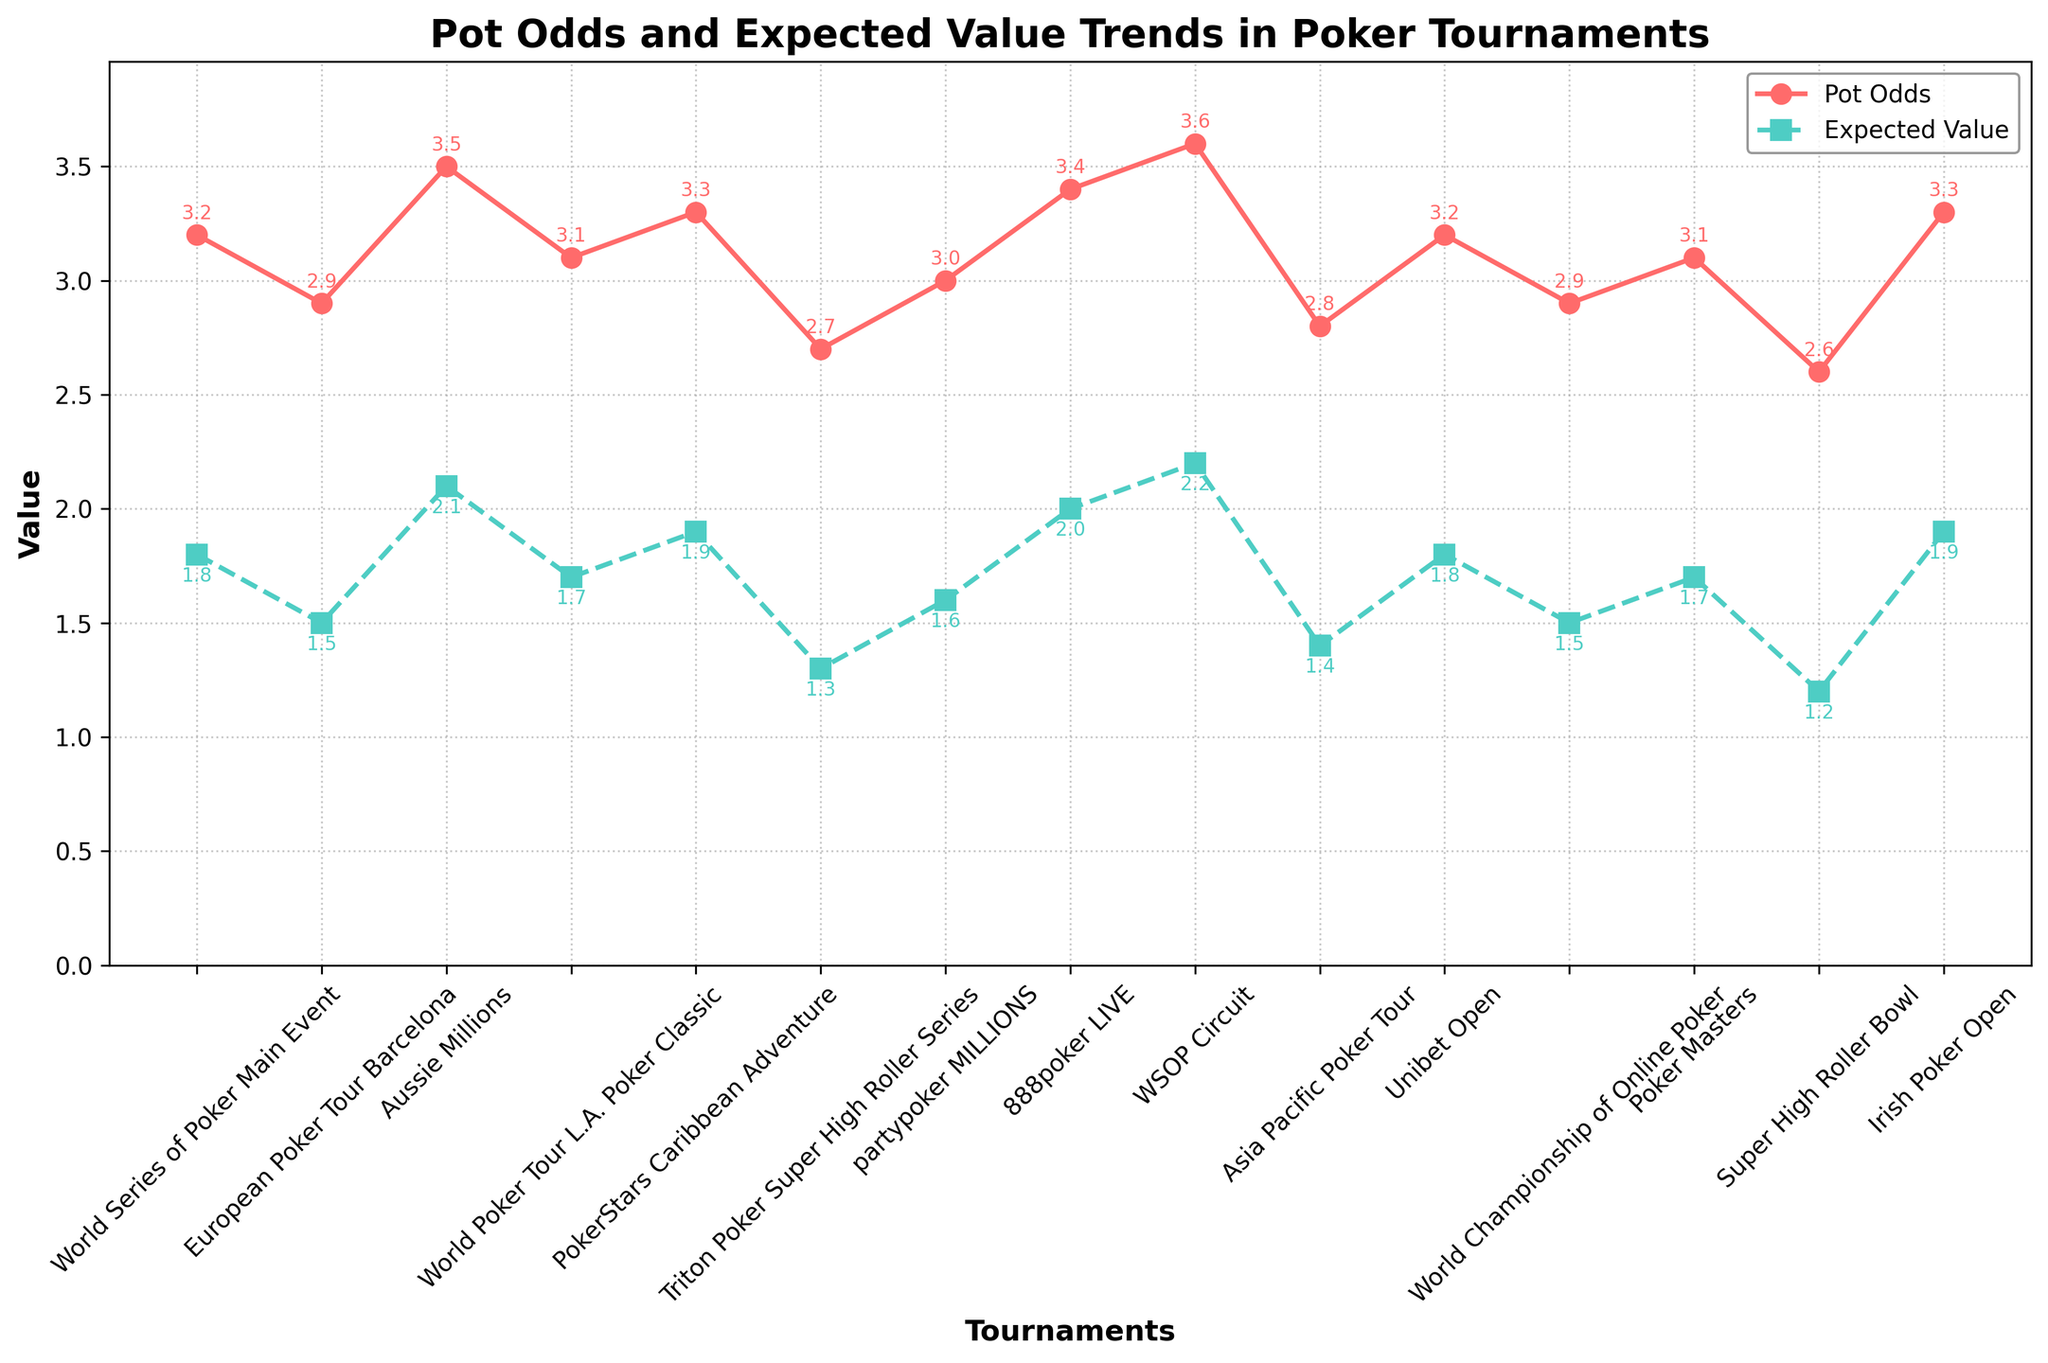What is the difference between the highest and lowest Pot Odds values? The highest Pot Odds value is 3.6 (WSOP Circuit) and the lowest is 2.6 (Super High Roller Bowl). The difference is calculated as 3.6 - 2.6 = 1.0
Answer: 1.0 Which tournament has the highest Expected Value? Looking at the Expected Value trendline, the WSOP Circuit has the highest Expected Value at 2.2
Answer: WSOP Circuit Are there any tournaments where the Pot Odds and Expected Value are identical? By examining the annotated numbers on the plots, no tournament shows identical Pot Odds and Expected Value values. The closest pairs differ by at least 0.1
Answer: No Which tournament has the lowest Pot Odds, and what is the corresponding Expected Value? The Super High Roller Bowl has the lowest Pot Odds at 2.6. The corresponding Expected Value for this tournament is 1.2
Answer: Super High Roller Bowl, 1.2 What is the average Expected Value across all tournaments? Sum all Expected Values: 1.8 + 1.5 + 2.1 + 1.7 + 1.9 + 1.3 + 1.6 + 2.0 + 2.2 + 1.4 + 1.8 + 1.5 + 1.7 + 1.2 + 1.9 = 26.6. The number of tournaments is 15. The average is calculated as 26.6 / 15 = 1.77
Answer: 1.77 How do the Pot Odds of the World Series of Poker Main Event compare to the Expected Value of the PokerStars Caribbean Adventure? The Pot Odds for the World Series of Poker Main Event is 3.2, while the Expected Value of the PokerStars Caribbean Adventure is 1.9. Therefore, the Pot Odds for the Main Event is greater
Answer: Greater Which tournament has the highest Pot Odds, and how does its Expected Value rank among all tournaments? The WSOP Circuit has the highest Pot Odds at 3.6. Its Expected Value is 2.2, which is the highest among all tournaments
Answer: WSOP Circuit, highest Do any tournaments show a Pot Odds value of exactly 3.0? Yes, the partypoker MILLIONS shows a Pot Odds value exactly at 3.0
Answer: Yes In which tournament does the Expected Value differ the most compared to its Pot Odds? The biggest difference between Pot Odds and Expected Value can be found by comparing the values of each tournament. The Aussie Millions (3.5 Pot Odds - 2.1 Expected Value = 1.4 difference) has the largest gap
Answer: Aussie Millions Which tournament has the closest Pot Odds and Expected Value, and what are those values? By visually checking the plots, the World Series of Poker Main Event and the Unibet Open both have Pot Odds at 3.2 and Expected Value at 1.8, showing an equal closest difference of 1.4
Answer: World Series of Poker Main Event & Unibet Open, Pot Odds: 3.2, Expected Value: 1.8 